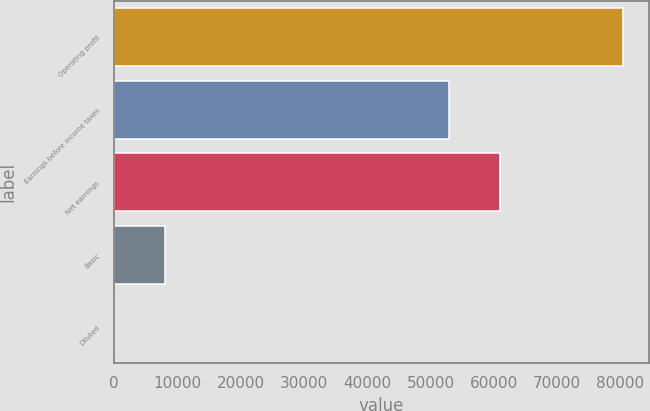<chart> <loc_0><loc_0><loc_500><loc_500><bar_chart><fcel>Operating profit<fcel>Earnings before income taxes<fcel>Net earnings<fcel>Basic<fcel>Diluted<nl><fcel>80407<fcel>52954<fcel>60994.7<fcel>8041.08<fcel>0.42<nl></chart> 